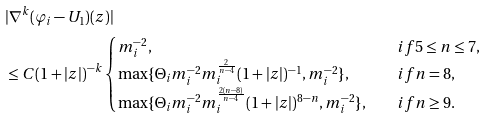Convert formula to latex. <formula><loc_0><loc_0><loc_500><loc_500>& | \nabla ^ { k } ( \varphi _ { i } - U _ { 1 } ) ( z ) | \\ & \leq C ( 1 + | z | ) ^ { - k } \begin{cases} m _ { i } ^ { - 2 } , & \quad i f 5 \leq n \leq 7 , \\ \max \{ \Theta _ { i } m _ { i } ^ { - 2 } m _ { i } ^ { \frac { 2 } { n - 4 } } ( 1 + | z | ) ^ { - 1 } , m _ { i } ^ { - 2 } \} , & \quad i f n = 8 , \\ \max \{ \Theta _ { i } m _ { i } ^ { - 2 } m _ { i } ^ { \frac { 2 ( n - 8 ) } { n - 4 } } ( 1 + | z | ) ^ { 8 - n } , m _ { i } ^ { - 2 } \} , & \quad i f n \geq 9 . \end{cases}</formula> 